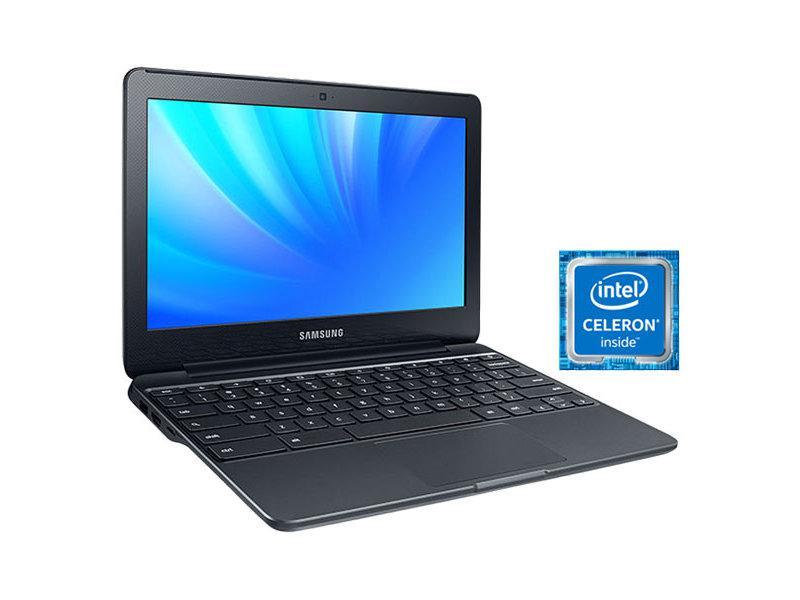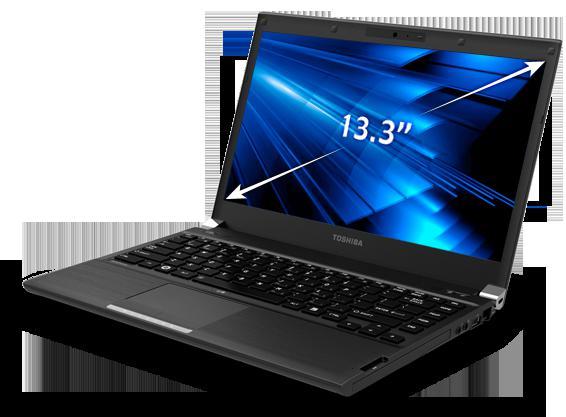The first image is the image on the left, the second image is the image on the right. Assess this claim about the two images: "The screen on the left is displayed head-on, and the screen on the right is angled facing left.". Correct or not? Answer yes or no. No. The first image is the image on the left, the second image is the image on the right. Assess this claim about the two images: "In at least one image there is one powered on laptop that top side is black and base is silver.". Correct or not? Answer yes or no. No. 